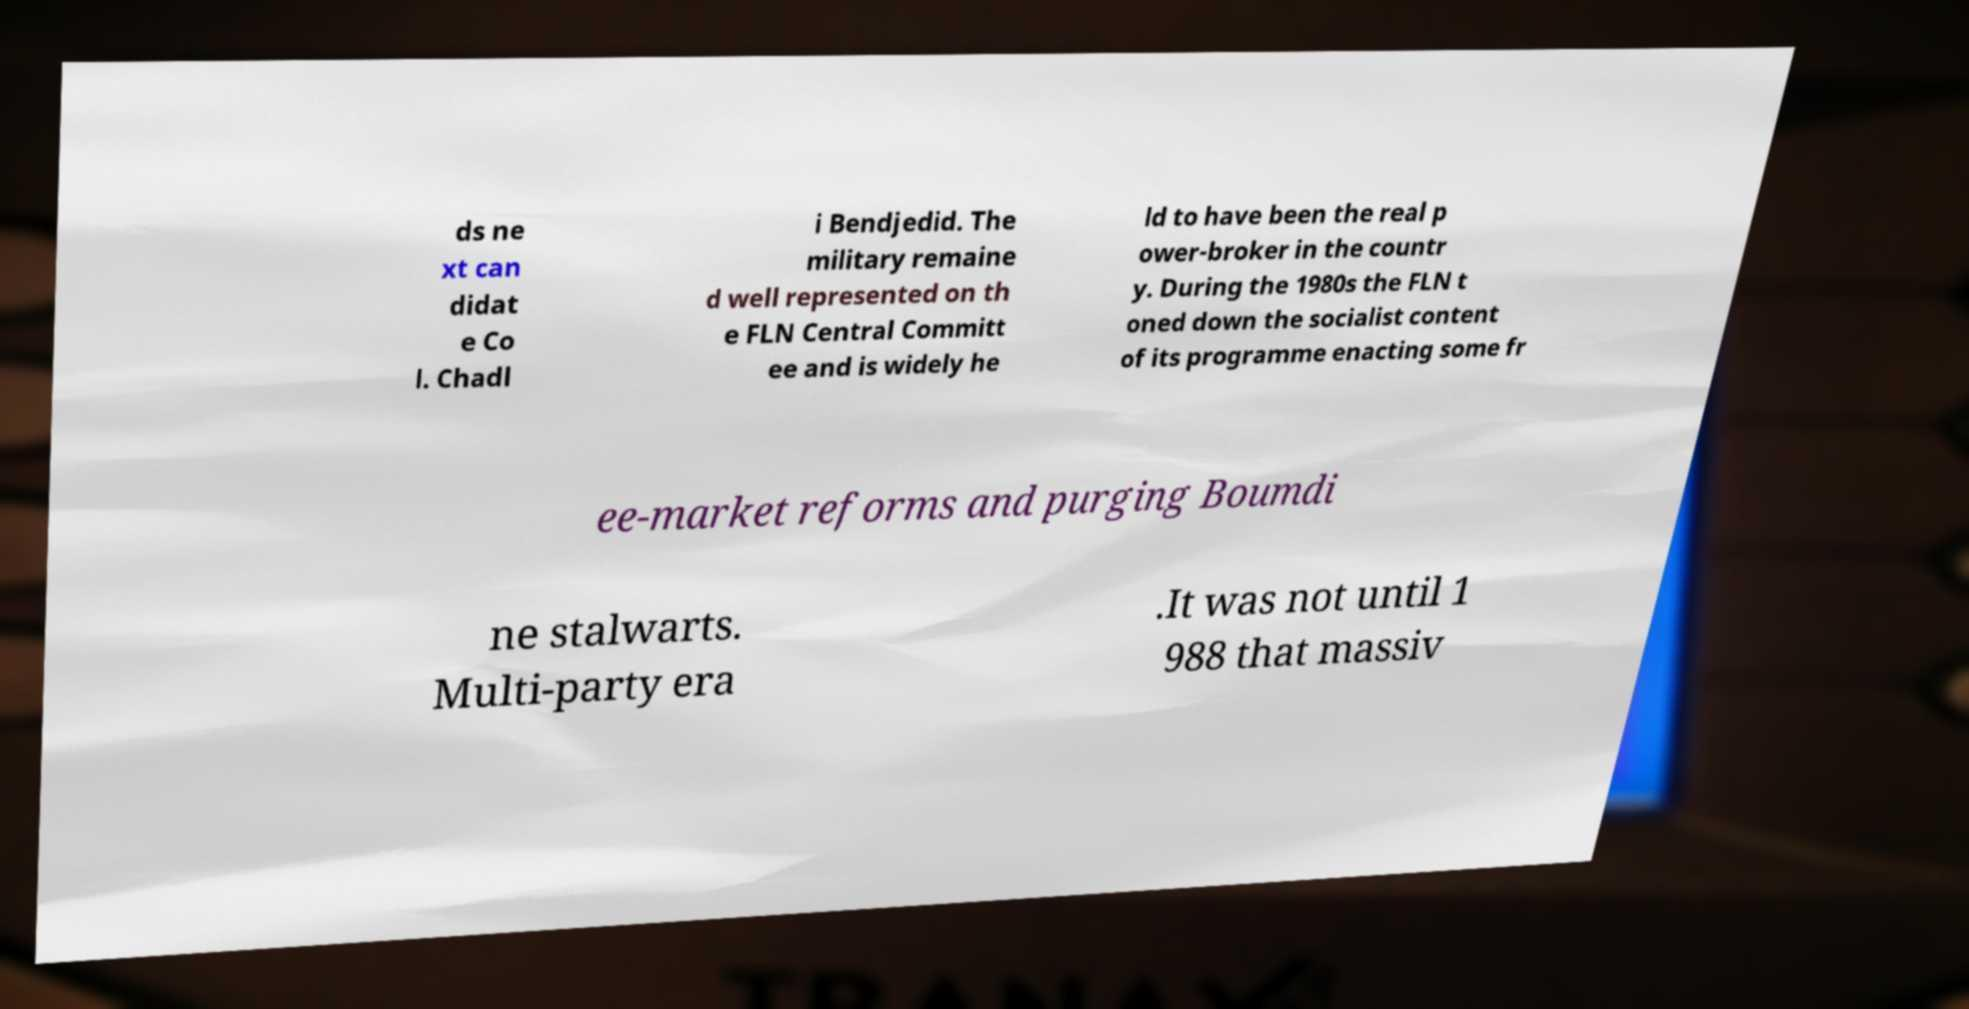What messages or text are displayed in this image? I need them in a readable, typed format. ds ne xt can didat e Co l. Chadl i Bendjedid. The military remaine d well represented on th e FLN Central Committ ee and is widely he ld to have been the real p ower-broker in the countr y. During the 1980s the FLN t oned down the socialist content of its programme enacting some fr ee-market reforms and purging Boumdi ne stalwarts. Multi-party era .It was not until 1 988 that massiv 